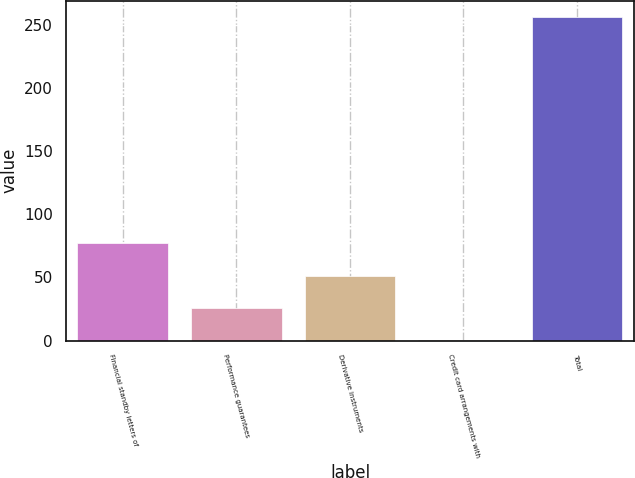Convert chart. <chart><loc_0><loc_0><loc_500><loc_500><bar_chart><fcel>Financial standby letters of<fcel>Performance guarantees<fcel>Derivative instruments<fcel>Credit card arrangements with<fcel>Total<nl><fcel>77.19<fcel>25.93<fcel>51.56<fcel>0.3<fcel>256.6<nl></chart> 